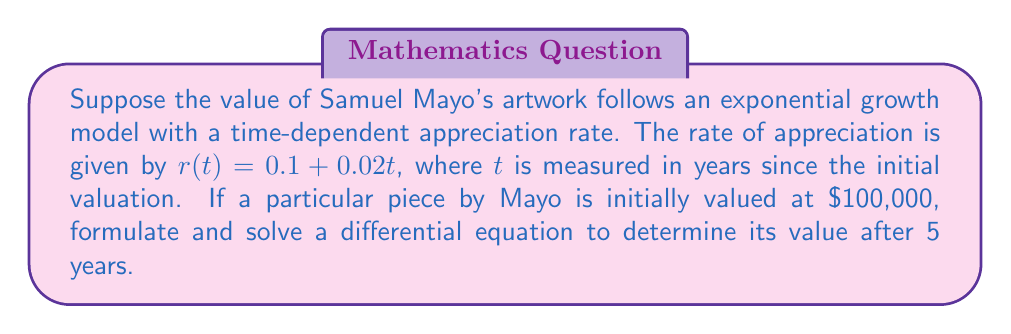Can you solve this math problem? Let's approach this step-by-step:

1) Let $V(t)$ represent the value of the artwork at time $t$.

2) The rate of change of the artwork's value is proportional to its current value and the appreciation rate. This can be expressed as:

   $$\frac{dV}{dt} = r(t)V$$

3) Substituting the given appreciation rate:

   $$\frac{dV}{dt} = (0.1 + 0.02t)V$$

4) This is a separable differential equation. We can solve it by separating variables:

   $$\frac{dV}{V} = (0.1 + 0.02t)dt$$

5) Integrating both sides:

   $$\int \frac{dV}{V} = \int (0.1 + 0.02t)dt$$

6) Solving the integrals:

   $$\ln|V| = 0.1t + 0.01t^2 + C$$

7) Taking the exponential of both sides:

   $$V = e^{0.1t + 0.01t^2 + C} = Ae^{0.1t + 0.01t^2}$$

   where $A = e^C$ is a constant.

8) Using the initial condition $V(0) = 100,000$:

   $$100,000 = Ae^0 = A$$

9) Therefore, the general solution is:

   $$V(t) = 100,000e^{0.1t + 0.01t^2}$$

10) To find the value after 5 years, we substitute $t = 5$:

    $$V(5) = 100,000e^{0.1(5) + 0.01(5^2)} = 100,000e^{0.5 + 0.25} = 100,000e^{0.75}$$

11) Calculating the final value:

    $$V(5) \approx 211,803.40$$
Answer: $211,803.40 